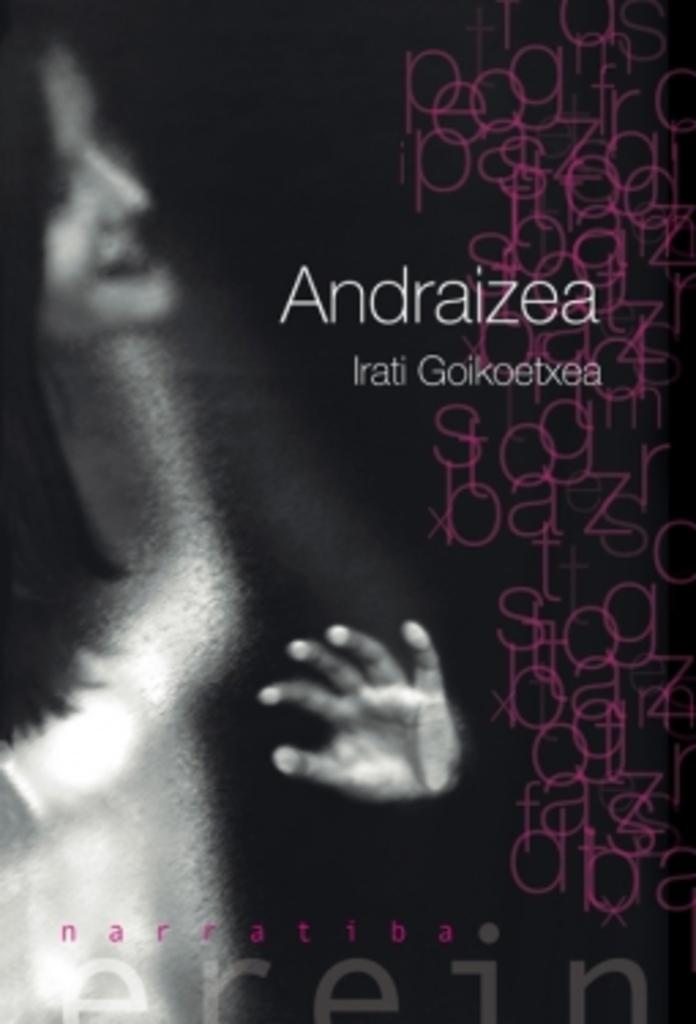<image>
Summarize the visual content of the image. The title for the woman on the poster is Andraizea Irati Goikoetxee. 